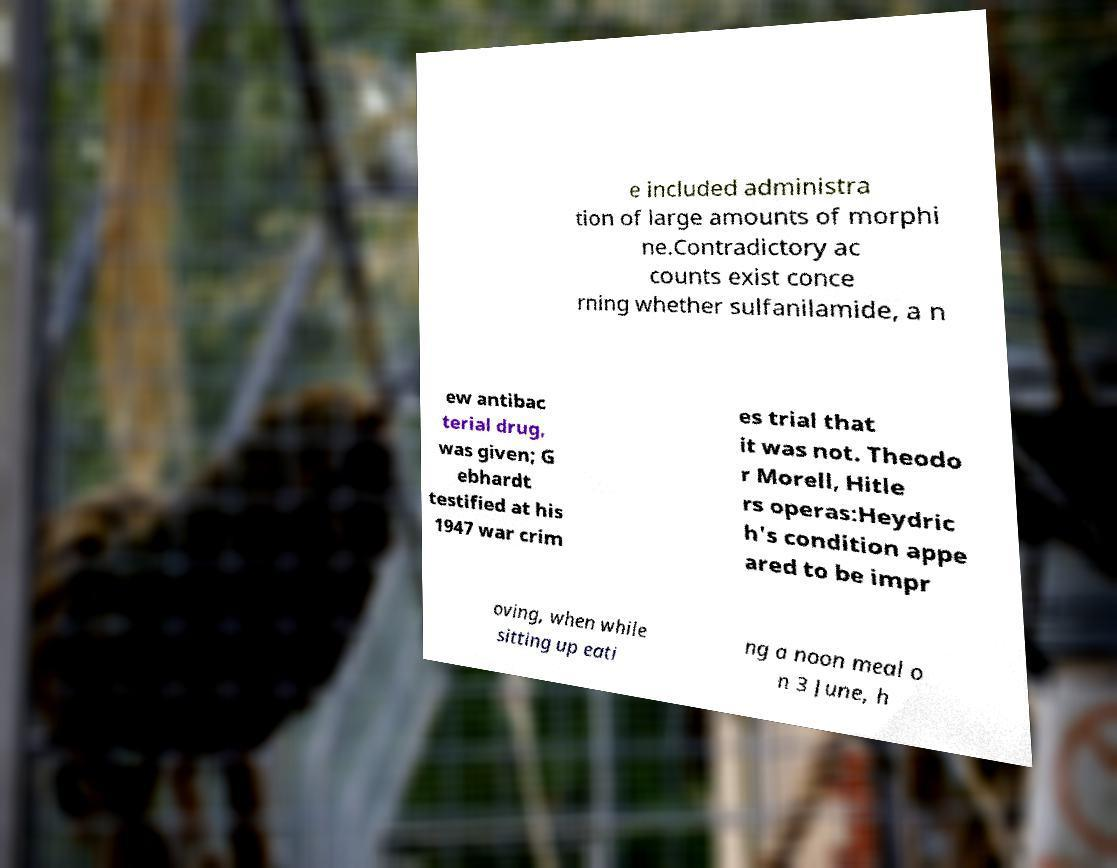There's text embedded in this image that I need extracted. Can you transcribe it verbatim? e included administra tion of large amounts of morphi ne.Contradictory ac counts exist conce rning whether sulfanilamide, a n ew antibac terial drug, was given; G ebhardt testified at his 1947 war crim es trial that it was not. Theodo r Morell, Hitle rs operas:Heydric h's condition appe ared to be impr oving, when while sitting up eati ng a noon meal o n 3 June, h 